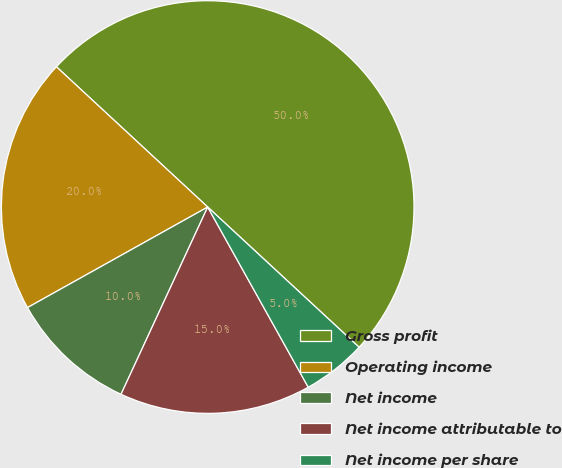<chart> <loc_0><loc_0><loc_500><loc_500><pie_chart><fcel>Gross profit<fcel>Operating income<fcel>Net income<fcel>Net income attributable to<fcel>Net income per share<nl><fcel>49.99%<fcel>20.0%<fcel>10.0%<fcel>15.0%<fcel>5.01%<nl></chart> 